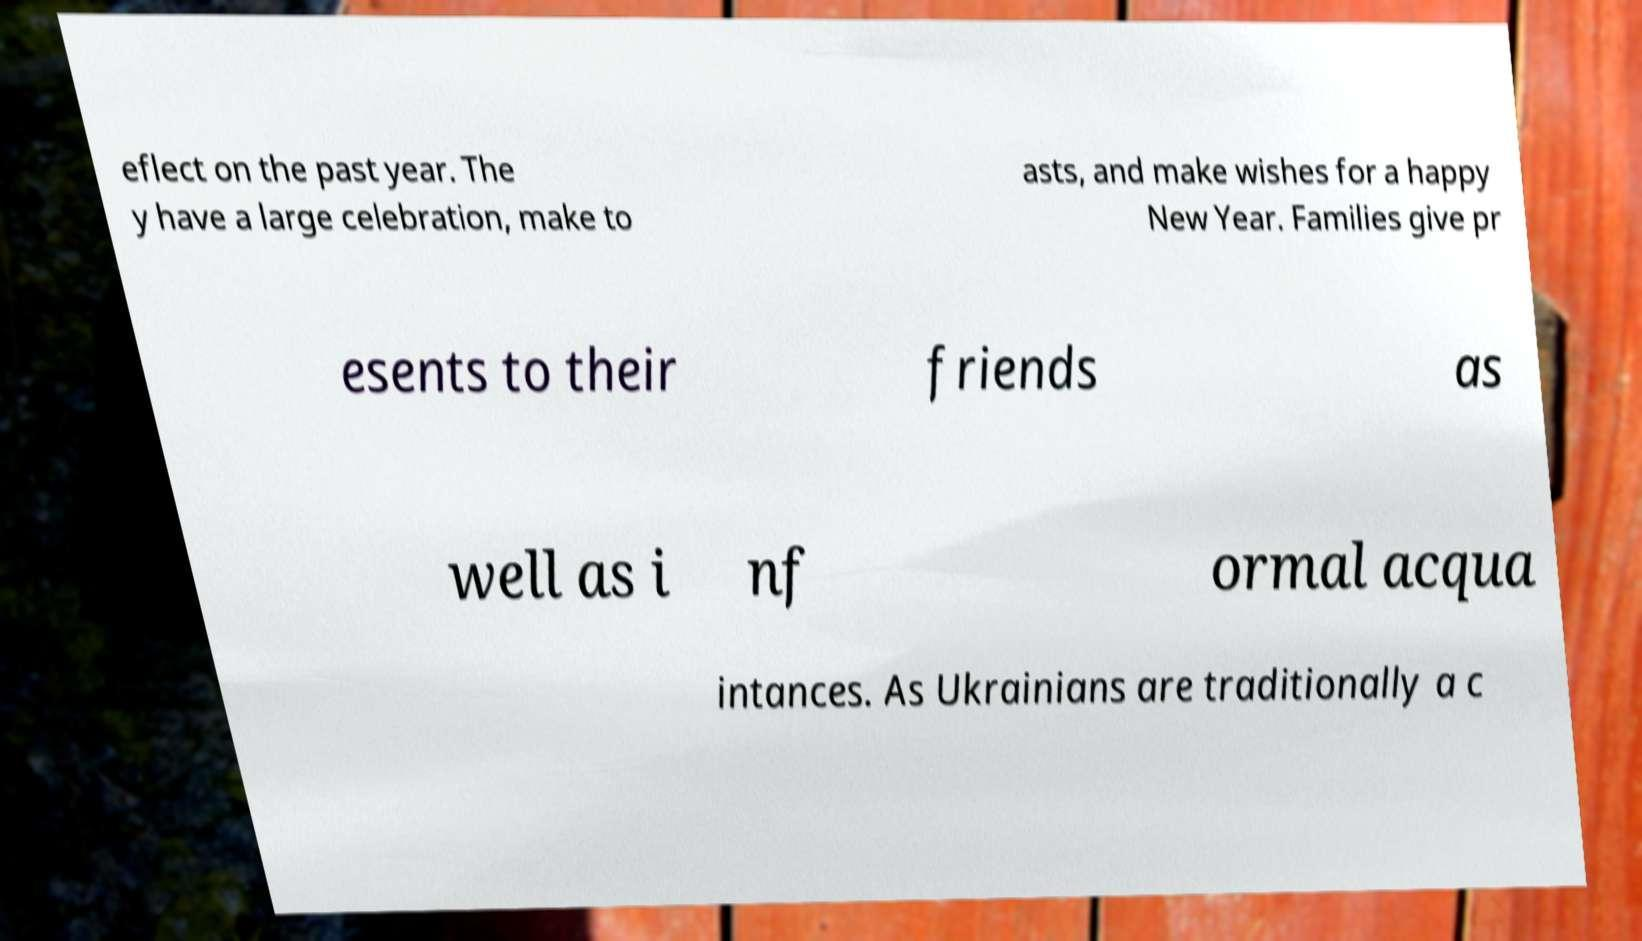Can you read and provide the text displayed in the image?This photo seems to have some interesting text. Can you extract and type it out for me? eflect on the past year. The y have a large celebration, make to asts, and make wishes for a happy New Year. Families give pr esents to their friends as well as i nf ormal acqua intances. As Ukrainians are traditionally a c 